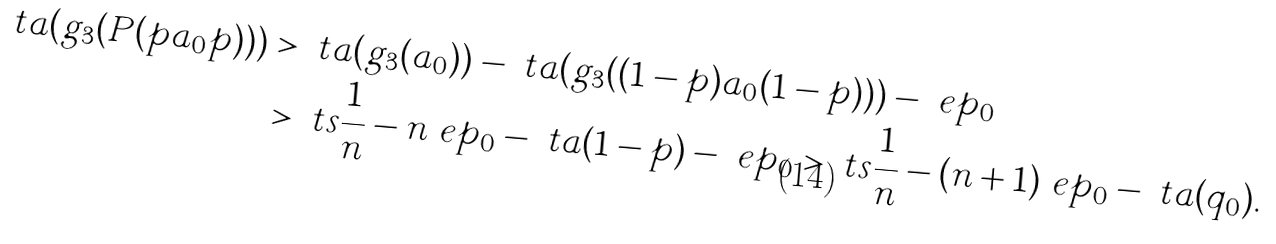<formula> <loc_0><loc_0><loc_500><loc_500>\ t a ( g _ { 3 } ( P ( p a _ { 0 } p ) ) ) & > \ t a ( g _ { 3 } ( a _ { 0 } ) ) - \ t a ( g _ { 3 } ( ( 1 - p ) a _ { 0 } ( 1 - p ) ) ) - \ e p _ { 0 } \\ & > \ t s { \frac { 1 } { n } } - n \ e p _ { 0 } - \ t a ( 1 - p ) - \ e p _ { 0 } > \ t s { \frac { 1 } { n } } - ( n + 1 ) \ e p _ { 0 } - \ t a ( q _ { 0 } ) .</formula> 